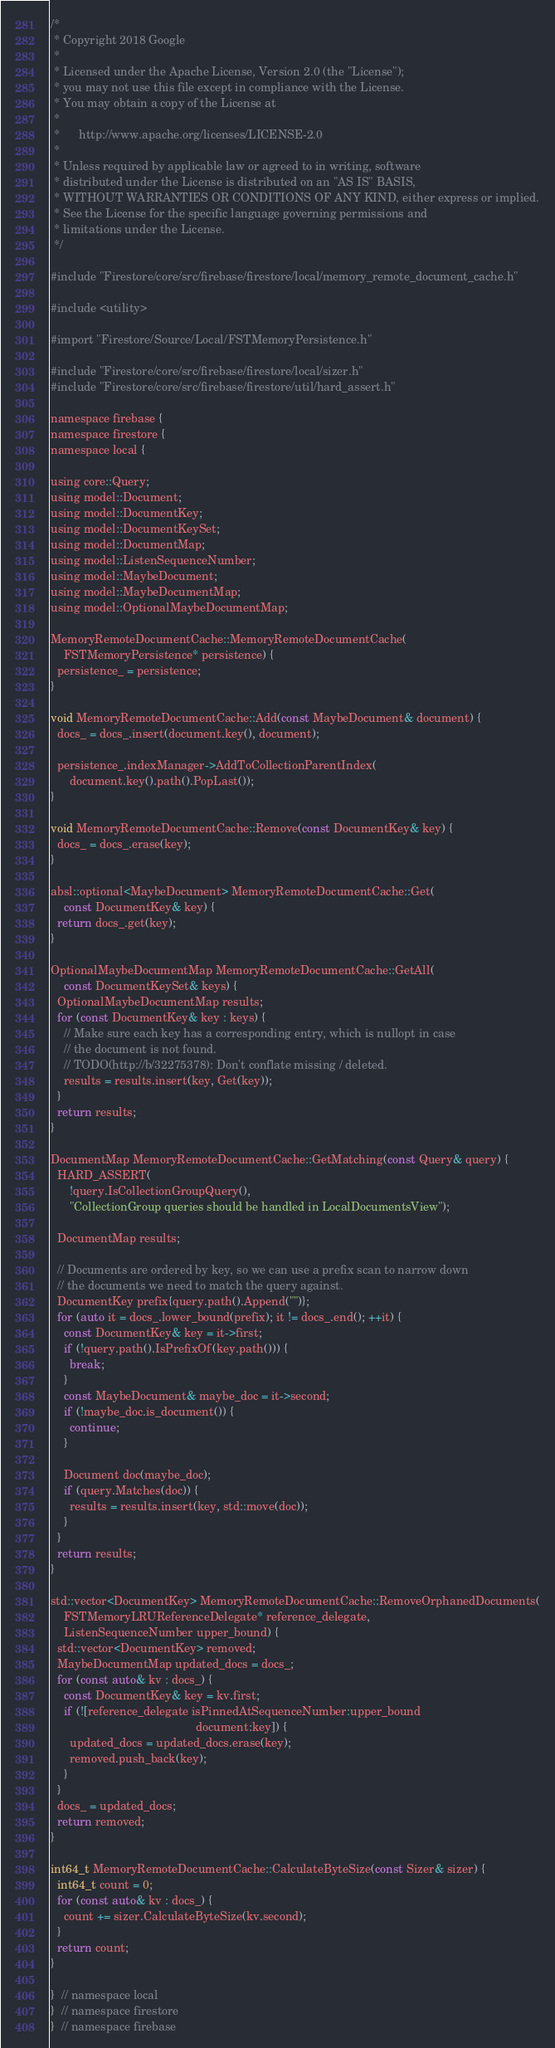<code> <loc_0><loc_0><loc_500><loc_500><_ObjectiveC_>/*
 * Copyright 2018 Google
 *
 * Licensed under the Apache License, Version 2.0 (the "License");
 * you may not use this file except in compliance with the License.
 * You may obtain a copy of the License at
 *
 *      http://www.apache.org/licenses/LICENSE-2.0
 *
 * Unless required by applicable law or agreed to in writing, software
 * distributed under the License is distributed on an "AS IS" BASIS,
 * WITHOUT WARRANTIES OR CONDITIONS OF ANY KIND, either express or implied.
 * See the License for the specific language governing permissions and
 * limitations under the License.
 */

#include "Firestore/core/src/firebase/firestore/local/memory_remote_document_cache.h"

#include <utility>

#import "Firestore/Source/Local/FSTMemoryPersistence.h"

#include "Firestore/core/src/firebase/firestore/local/sizer.h"
#include "Firestore/core/src/firebase/firestore/util/hard_assert.h"

namespace firebase {
namespace firestore {
namespace local {

using core::Query;
using model::Document;
using model::DocumentKey;
using model::DocumentKeySet;
using model::DocumentMap;
using model::ListenSequenceNumber;
using model::MaybeDocument;
using model::MaybeDocumentMap;
using model::OptionalMaybeDocumentMap;

MemoryRemoteDocumentCache::MemoryRemoteDocumentCache(
    FSTMemoryPersistence* persistence) {
  persistence_ = persistence;
}

void MemoryRemoteDocumentCache::Add(const MaybeDocument& document) {
  docs_ = docs_.insert(document.key(), document);

  persistence_.indexManager->AddToCollectionParentIndex(
      document.key().path().PopLast());
}

void MemoryRemoteDocumentCache::Remove(const DocumentKey& key) {
  docs_ = docs_.erase(key);
}

absl::optional<MaybeDocument> MemoryRemoteDocumentCache::Get(
    const DocumentKey& key) {
  return docs_.get(key);
}

OptionalMaybeDocumentMap MemoryRemoteDocumentCache::GetAll(
    const DocumentKeySet& keys) {
  OptionalMaybeDocumentMap results;
  for (const DocumentKey& key : keys) {
    // Make sure each key has a corresponding entry, which is nullopt in case
    // the document is not found.
    // TODO(http://b/32275378): Don't conflate missing / deleted.
    results = results.insert(key, Get(key));
  }
  return results;
}

DocumentMap MemoryRemoteDocumentCache::GetMatching(const Query& query) {
  HARD_ASSERT(
      !query.IsCollectionGroupQuery(),
      "CollectionGroup queries should be handled in LocalDocumentsView");

  DocumentMap results;

  // Documents are ordered by key, so we can use a prefix scan to narrow down
  // the documents we need to match the query against.
  DocumentKey prefix{query.path().Append("")};
  for (auto it = docs_.lower_bound(prefix); it != docs_.end(); ++it) {
    const DocumentKey& key = it->first;
    if (!query.path().IsPrefixOf(key.path())) {
      break;
    }
    const MaybeDocument& maybe_doc = it->second;
    if (!maybe_doc.is_document()) {
      continue;
    }

    Document doc(maybe_doc);
    if (query.Matches(doc)) {
      results = results.insert(key, std::move(doc));
    }
  }
  return results;
}

std::vector<DocumentKey> MemoryRemoteDocumentCache::RemoveOrphanedDocuments(
    FSTMemoryLRUReferenceDelegate* reference_delegate,
    ListenSequenceNumber upper_bound) {
  std::vector<DocumentKey> removed;
  MaybeDocumentMap updated_docs = docs_;
  for (const auto& kv : docs_) {
    const DocumentKey& key = kv.first;
    if (![reference_delegate isPinnedAtSequenceNumber:upper_bound
                                             document:key]) {
      updated_docs = updated_docs.erase(key);
      removed.push_back(key);
    }
  }
  docs_ = updated_docs;
  return removed;
}

int64_t MemoryRemoteDocumentCache::CalculateByteSize(const Sizer& sizer) {
  int64_t count = 0;
  for (const auto& kv : docs_) {
    count += sizer.CalculateByteSize(kv.second);
  }
  return count;
}

}  // namespace local
}  // namespace firestore
}  // namespace firebase
</code> 